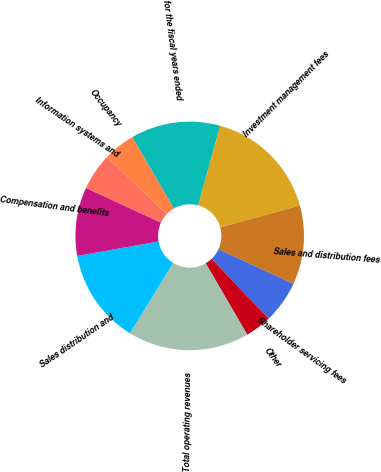Convert chart to OTSL. <chart><loc_0><loc_0><loc_500><loc_500><pie_chart><fcel>for the fiscal years ended<fcel>Investment management fees<fcel>Sales and distribution fees<fcel>Shareholder servicing fees<fcel>Other<fcel>Total operating revenues<fcel>Sales distribution and<fcel>Compensation and benefits<fcel>Information systems and<fcel>Occupancy<nl><fcel>12.69%<fcel>16.42%<fcel>11.19%<fcel>5.97%<fcel>3.73%<fcel>17.16%<fcel>13.43%<fcel>9.7%<fcel>5.23%<fcel>4.48%<nl></chart> 